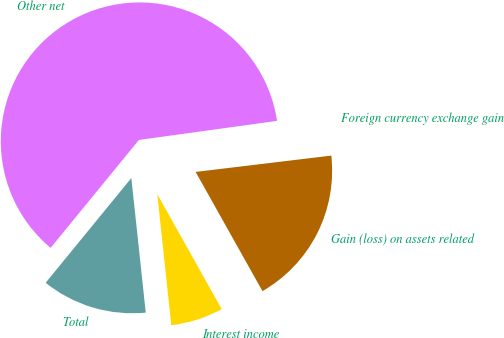<chart> <loc_0><loc_0><loc_500><loc_500><pie_chart><fcel>Interest income<fcel>Gain (loss) on assets related<fcel>Foreign currency exchange gain<fcel>Other net<fcel>Total<nl><fcel>6.44%<fcel>18.77%<fcel>0.28%<fcel>61.91%<fcel>12.61%<nl></chart> 